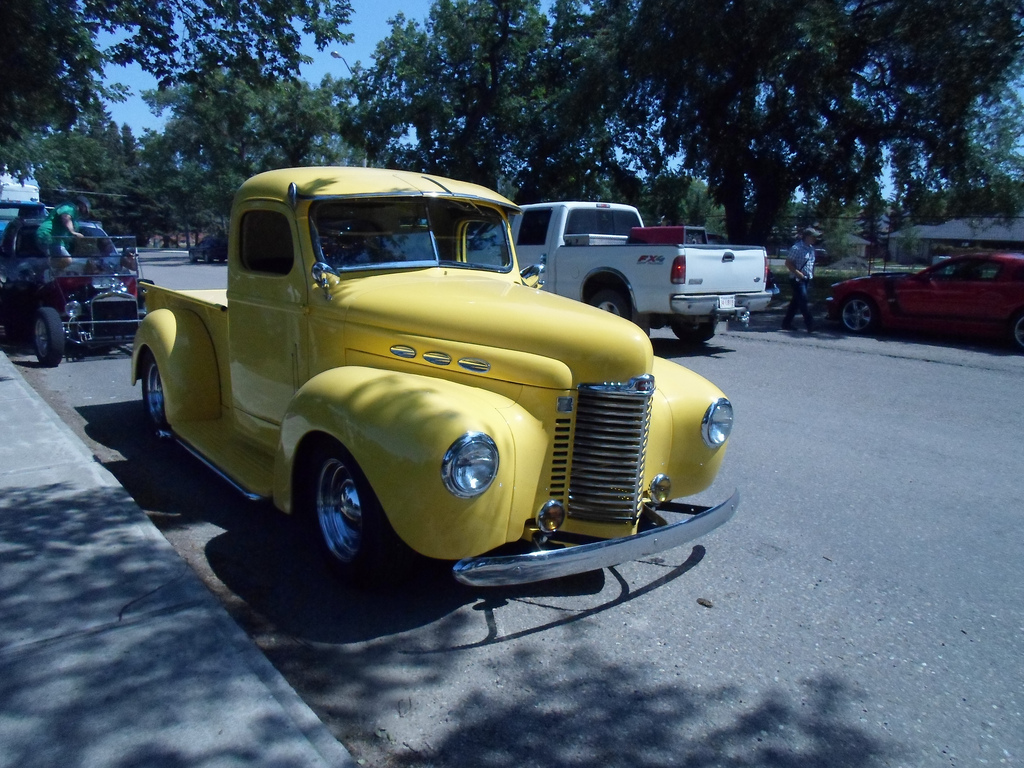What can you tell about the event where this photo was taken? This photo was likely taken at a vintage car show, an event where enthusiasts gather to display and admire classic automobiles. The presence of multiple well-maintained vintage vehicles and spectators suggests a communal appreciation for automotive history. How does the setting contribute to the atmosphere of the event? The setting, with its open-air environment, lined with trees and casual street parking, contributes a relaxed and friendly atmosphere, inviting community and conversations among like-minded enthusiasts. 